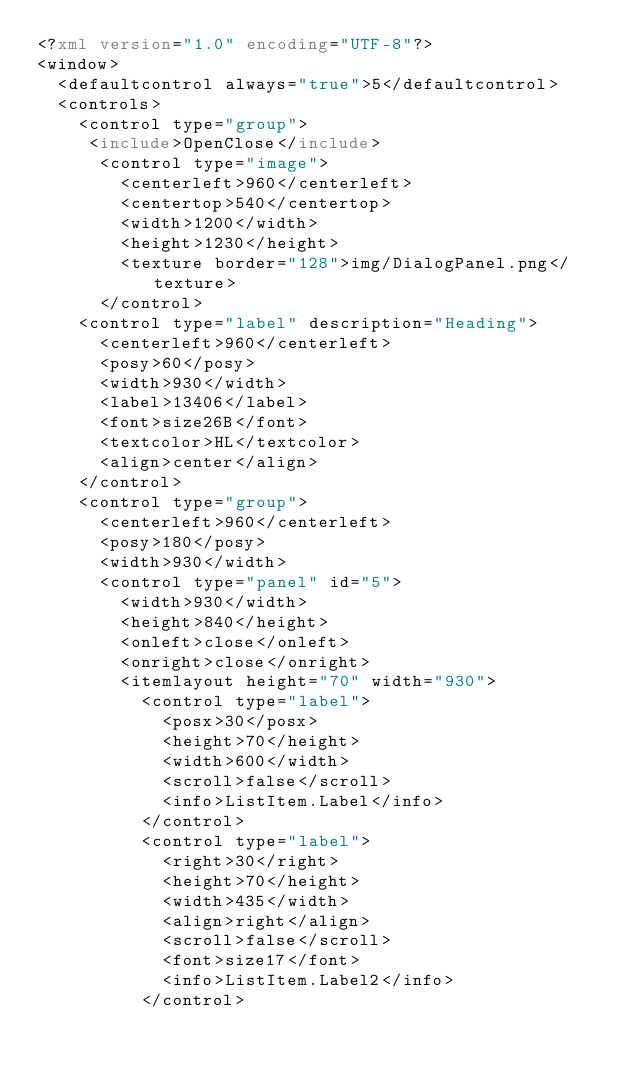<code> <loc_0><loc_0><loc_500><loc_500><_XML_><?xml version="1.0" encoding="UTF-8"?>
<window>
  <defaultcontrol always="true">5</defaultcontrol>
  <controls>
    <control type="group">
     <include>OpenClose</include>
		  <control type="image">
        <centerleft>960</centerleft>
        <centertop>540</centertop>
        <width>1200</width>
        <height>1230</height>
        <texture border="128">img/DialogPanel.png</texture>
      </control>
    <control type="label" description="Heading">
      <centerleft>960</centerleft>
      <posy>60</posy>
      <width>930</width>
      <label>13406</label>
      <font>size26B</font>
			<textcolor>HL</textcolor>
      <align>center</align>
    </control>
    <control type="group">
      <centerleft>960</centerleft>
      <posy>180</posy>
      <width>930</width>
			<control type="panel" id="5">
        <width>930</width>
        <height>840</height>
				<onleft>close</onleft>
				<onright>close</onright>
        <itemlayout height="70" width="930">
          <control type="label">
            <posx>30</posx>
            <height>70</height>
						<width>600</width>
            <scroll>false</scroll>
            <info>ListItem.Label</info>
          </control>
          <control type="label">
            <right>30</right>
            <height>70</height>
						<width>435</width>
            <align>right</align>
            <scroll>false</scroll>
            <font>size17</font>
            <info>ListItem.Label2</info>
          </control></code> 